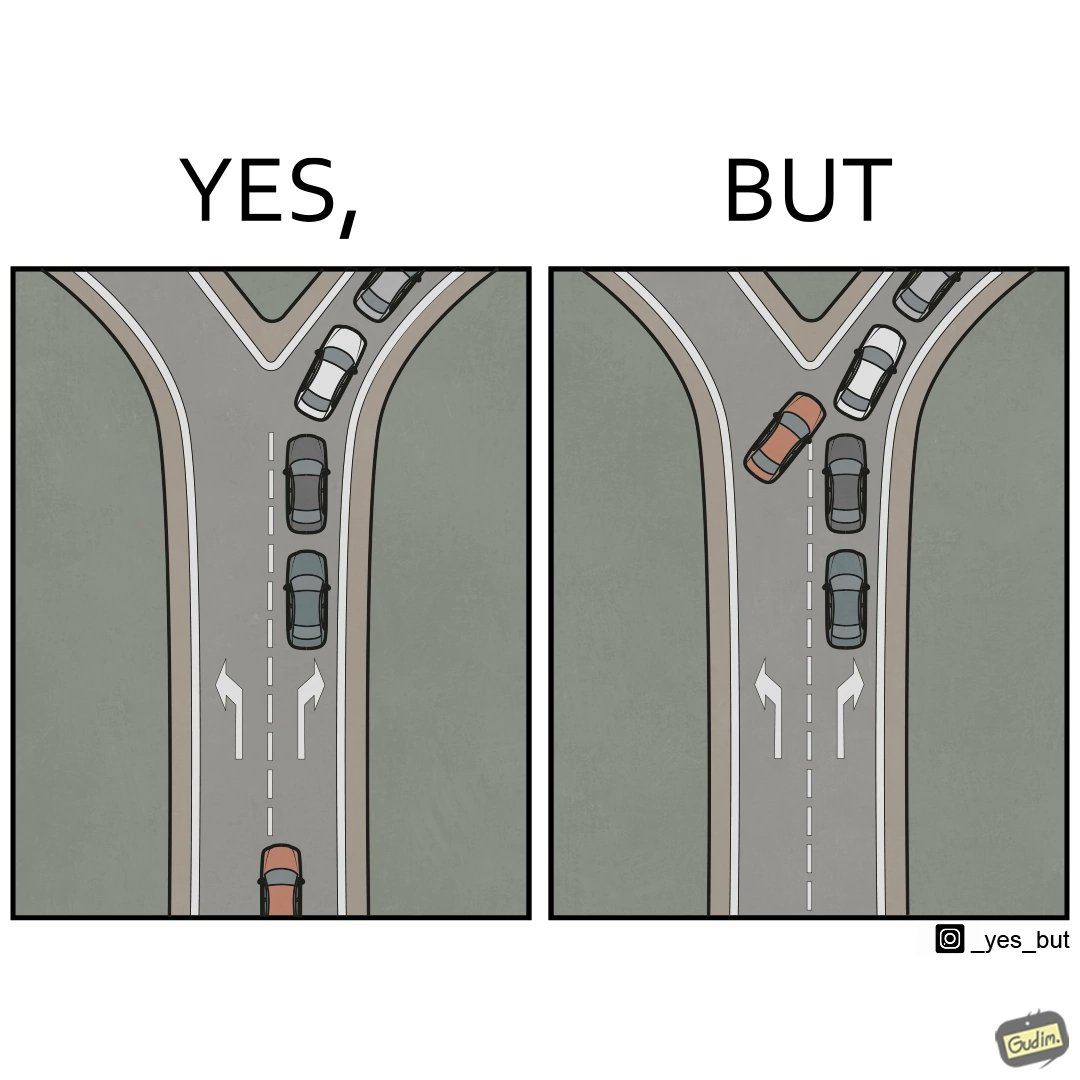What is shown in this image? This image is funny, as a car is approaching a Y junction, with the left fork empty, and the right fork filled with a line of cars. If it needs to go to the right, it should get behind the line of cars. However, in an attempt to probably go faster, the car tries to cut in line, leading to more traffic,  thereby increasing commute time. 